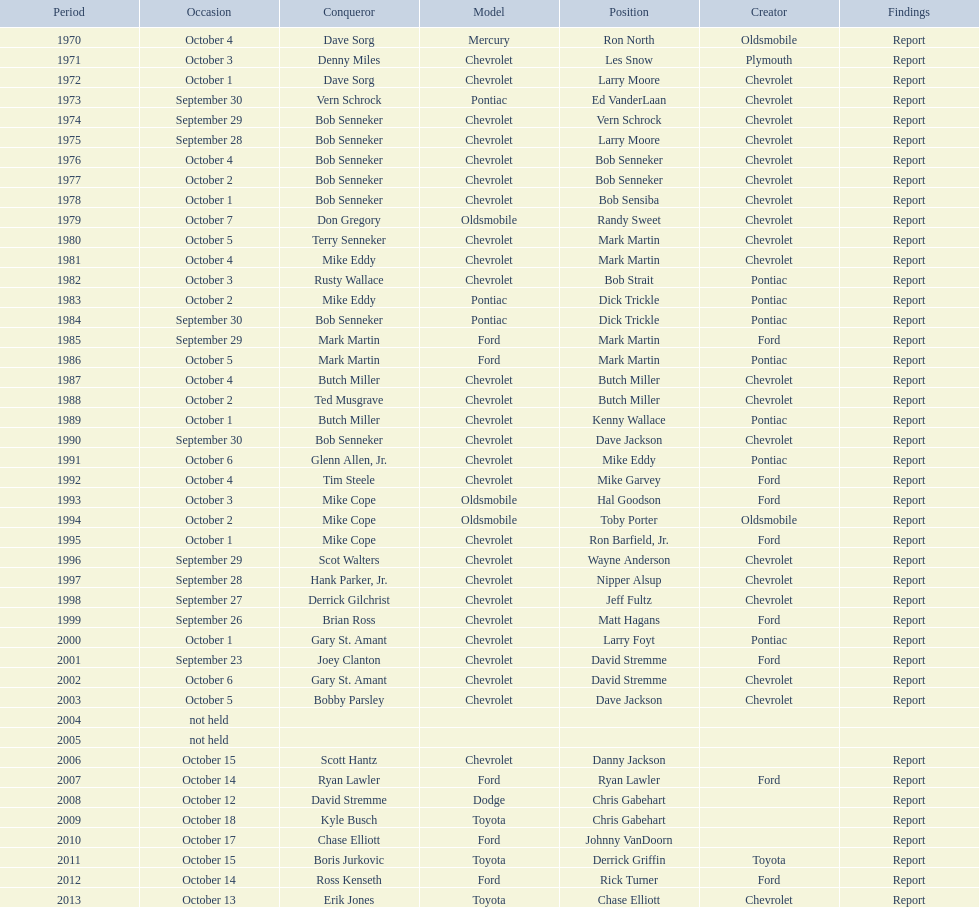Which make of car was used the least by those that won races? Toyota. 